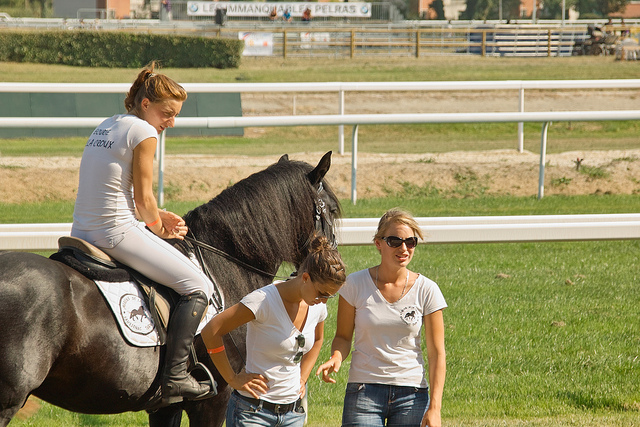Identify the text displayed in this image. PELRAS 